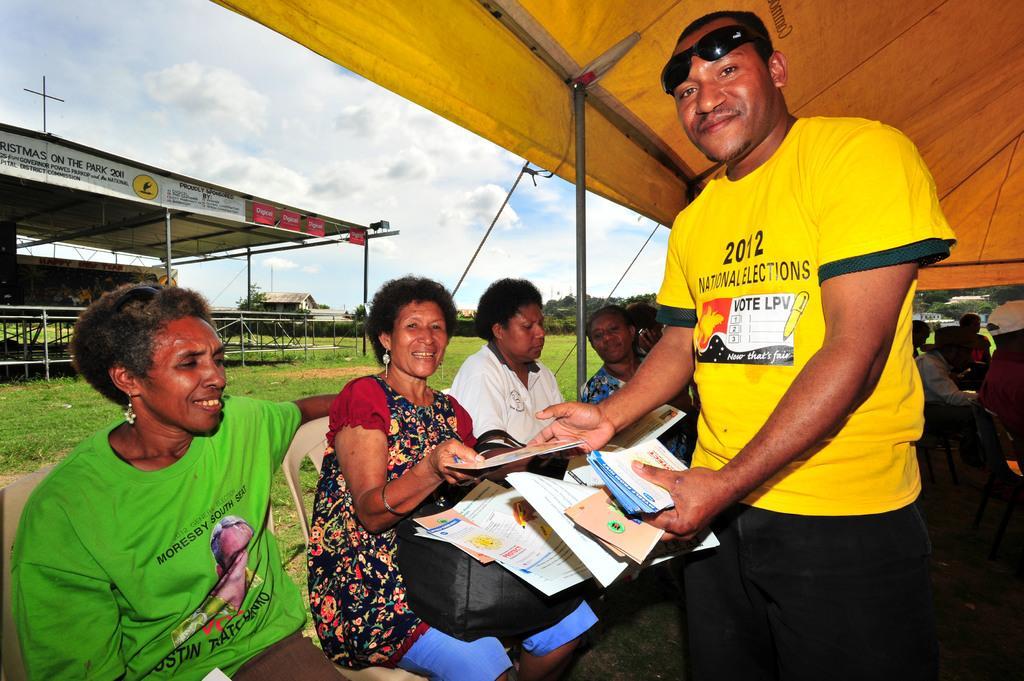Please provide a concise description of this image. In this image we can see a person is standing, he is holding some papers in his hand and he is wearing yellow color t-shirt and black pant. Beside him so many people are sitting on chairs. These people are sitting under yellow color shelter. Background of the image one more shelter is present and sky is full of clouds. 